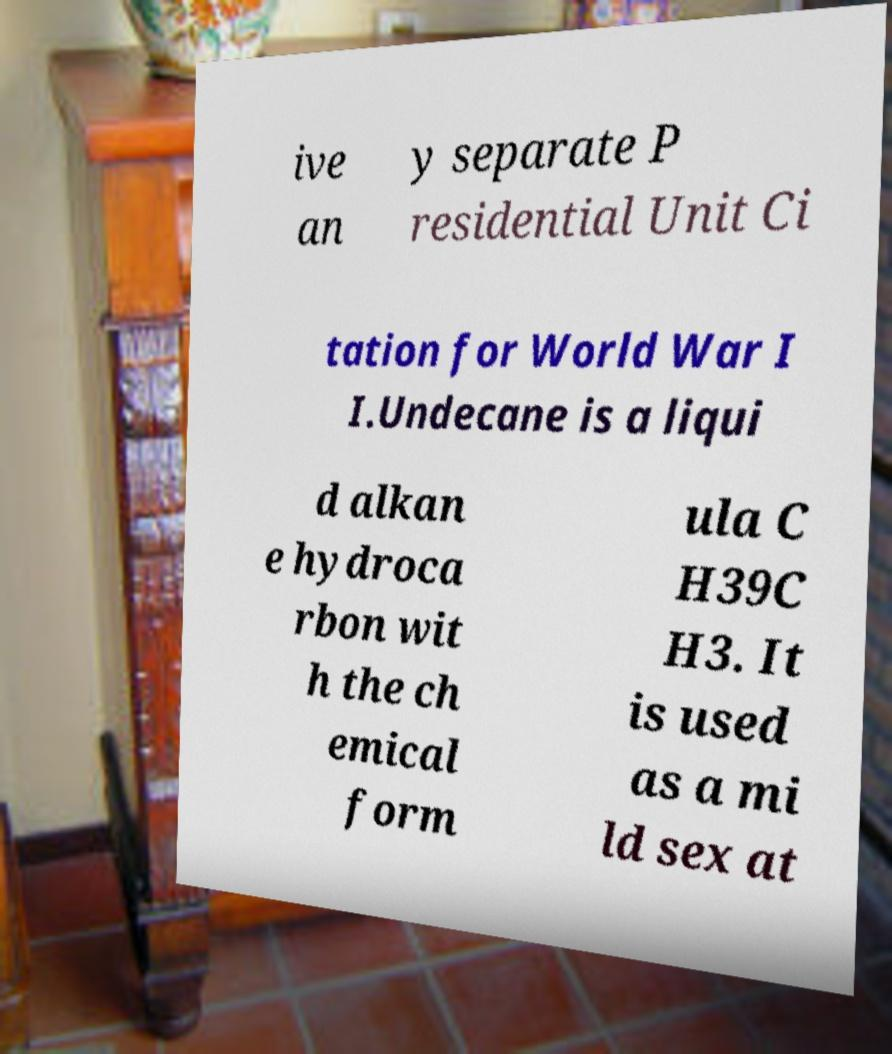Can you read and provide the text displayed in the image?This photo seems to have some interesting text. Can you extract and type it out for me? ive an y separate P residential Unit Ci tation for World War I I.Undecane is a liqui d alkan e hydroca rbon wit h the ch emical form ula C H39C H3. It is used as a mi ld sex at 